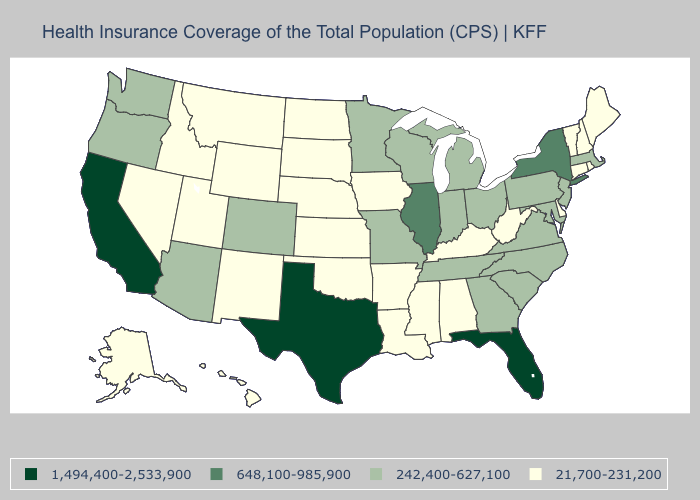What is the value of Kentucky?
Be succinct. 21,700-231,200. Which states have the lowest value in the USA?
Short answer required. Alabama, Alaska, Arkansas, Connecticut, Delaware, Hawaii, Idaho, Iowa, Kansas, Kentucky, Louisiana, Maine, Mississippi, Montana, Nebraska, Nevada, New Hampshire, New Mexico, North Dakota, Oklahoma, Rhode Island, South Dakota, Utah, Vermont, West Virginia, Wyoming. Name the states that have a value in the range 648,100-985,900?
Keep it brief. Illinois, New York. What is the value of Ohio?
Concise answer only. 242,400-627,100. Which states hav the highest value in the West?
Keep it brief. California. What is the highest value in states that border Indiana?
Write a very short answer. 648,100-985,900. Does the first symbol in the legend represent the smallest category?
Short answer required. No. What is the lowest value in states that border Maryland?
Be succinct. 21,700-231,200. What is the value of Louisiana?
Give a very brief answer. 21,700-231,200. Does Mississippi have the lowest value in the South?
Give a very brief answer. Yes. Name the states that have a value in the range 21,700-231,200?
Give a very brief answer. Alabama, Alaska, Arkansas, Connecticut, Delaware, Hawaii, Idaho, Iowa, Kansas, Kentucky, Louisiana, Maine, Mississippi, Montana, Nebraska, Nevada, New Hampshire, New Mexico, North Dakota, Oklahoma, Rhode Island, South Dakota, Utah, Vermont, West Virginia, Wyoming. Which states have the lowest value in the South?
Answer briefly. Alabama, Arkansas, Delaware, Kentucky, Louisiana, Mississippi, Oklahoma, West Virginia. What is the value of Louisiana?
Short answer required. 21,700-231,200. What is the value of Missouri?
Give a very brief answer. 242,400-627,100. 